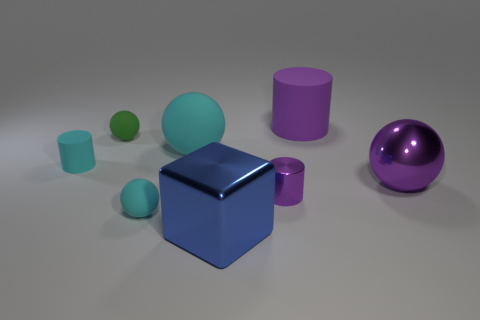What number of small red rubber balls are there? Upon closely examining the image, it's observed that there are actually no small red rubber balls present. The objects in the image include a blue cube, a purple sphere, and what appears to be various other geometric solids, but none match the description of a small red rubber ball. 